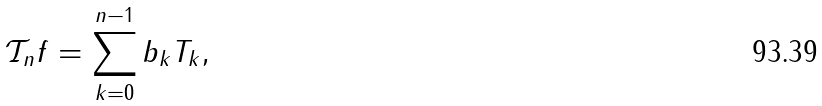<formula> <loc_0><loc_0><loc_500><loc_500>\mathcal { T } _ { n } f = \sum _ { k = 0 } ^ { n - 1 } b _ { k } T _ { k } ,</formula> 